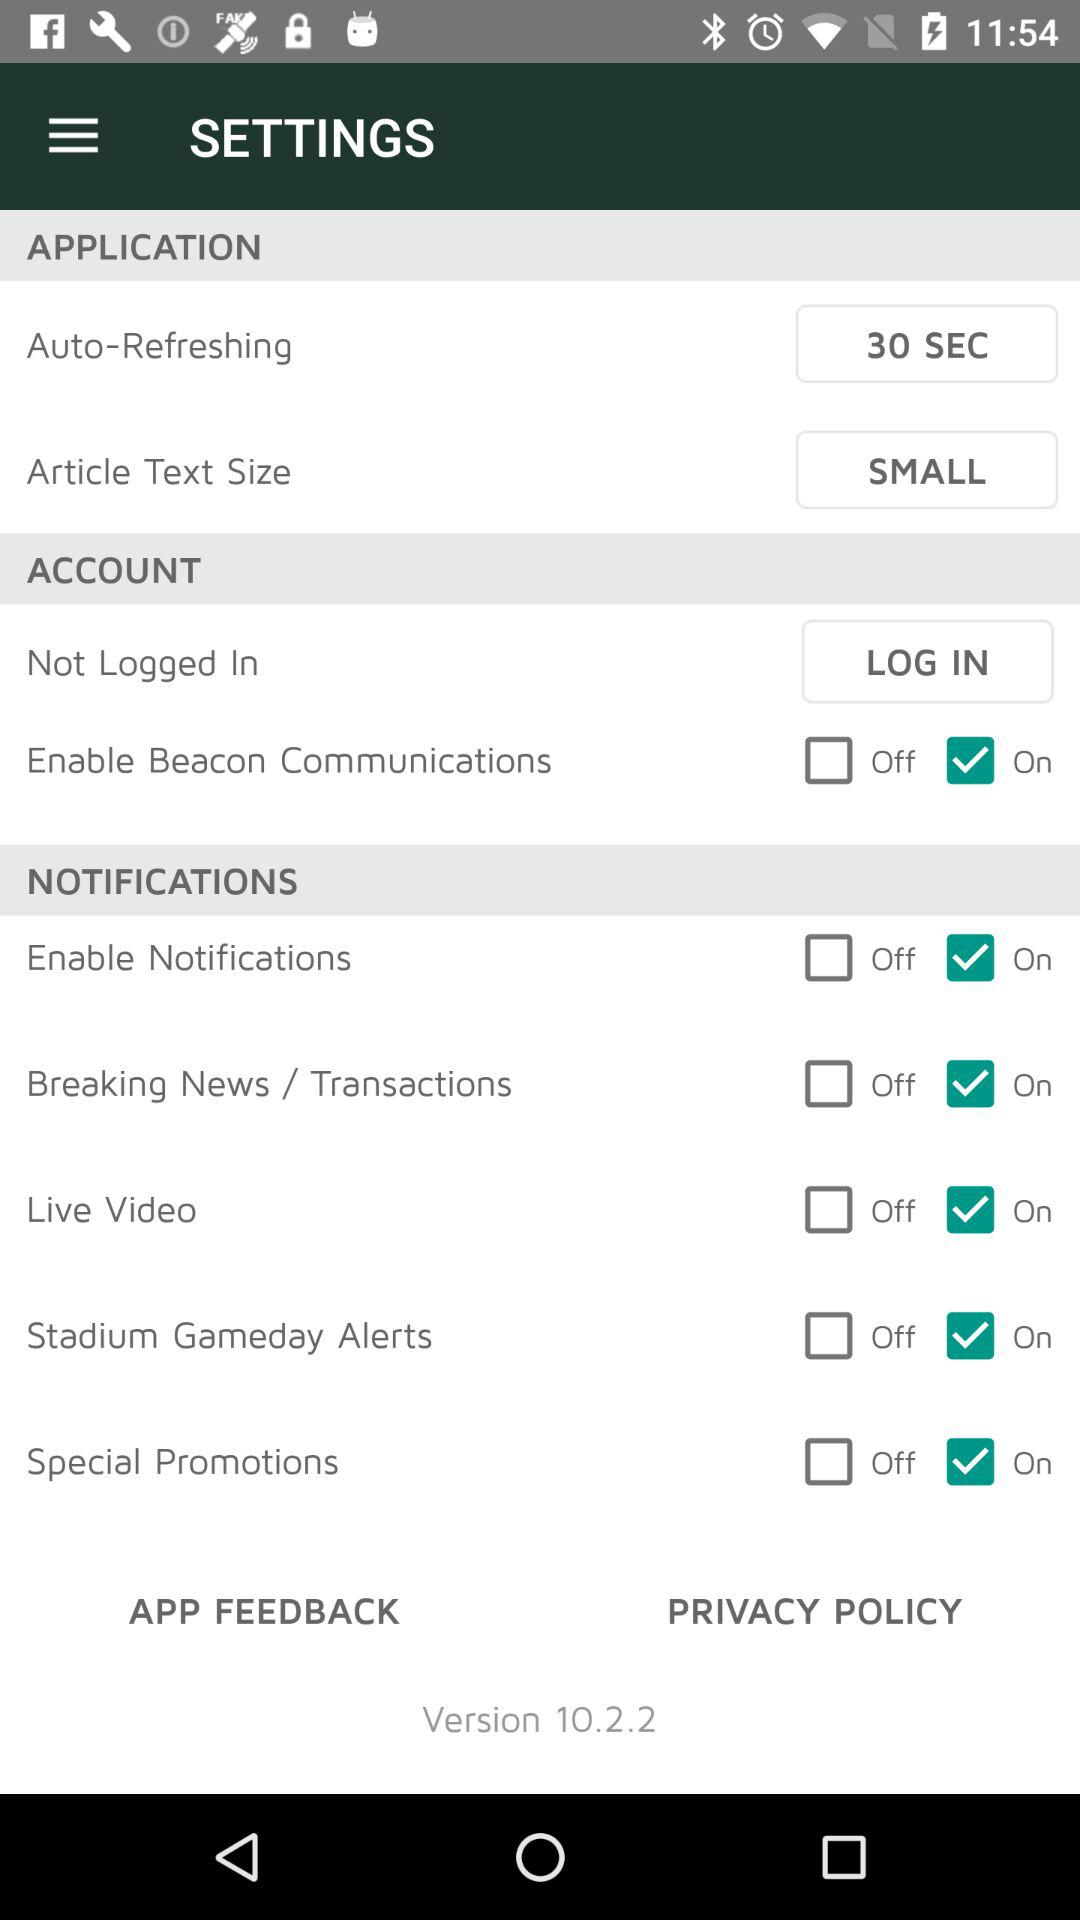What is the status of "Enable Beacon Communications"? The status is "on". 